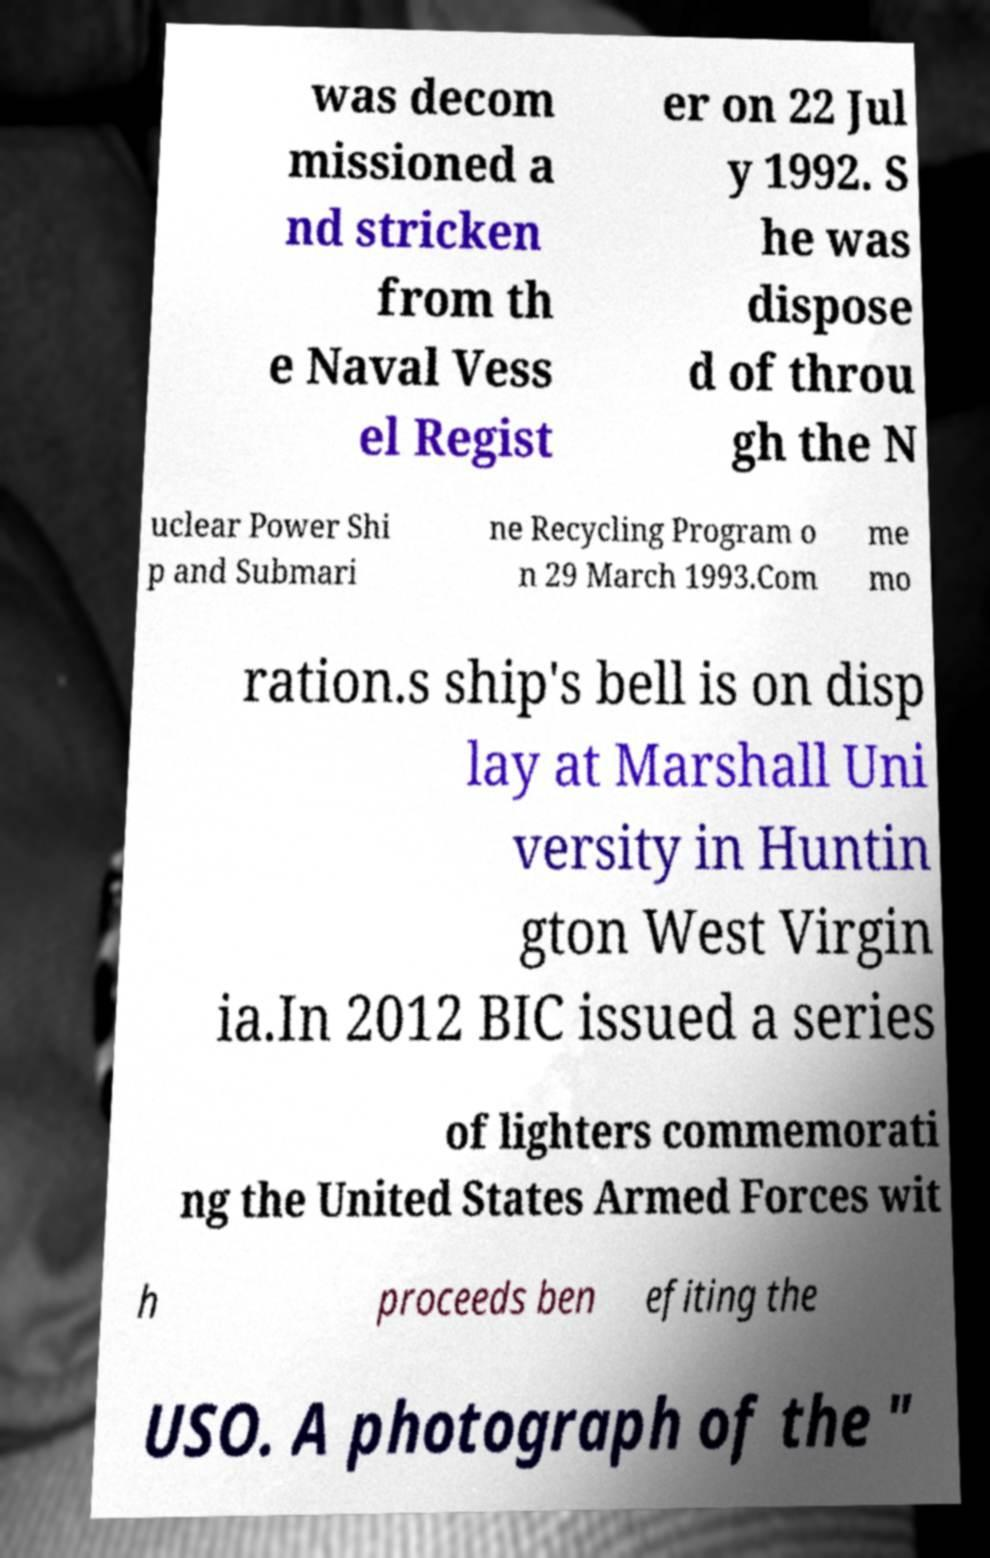For documentation purposes, I need the text within this image transcribed. Could you provide that? was decom missioned a nd stricken from th e Naval Vess el Regist er on 22 Jul y 1992. S he was dispose d of throu gh the N uclear Power Shi p and Submari ne Recycling Program o n 29 March 1993.Com me mo ration.s ship's bell is on disp lay at Marshall Uni versity in Huntin gton West Virgin ia.In 2012 BIC issued a series of lighters commemorati ng the United States Armed Forces wit h proceeds ben efiting the USO. A photograph of the " 